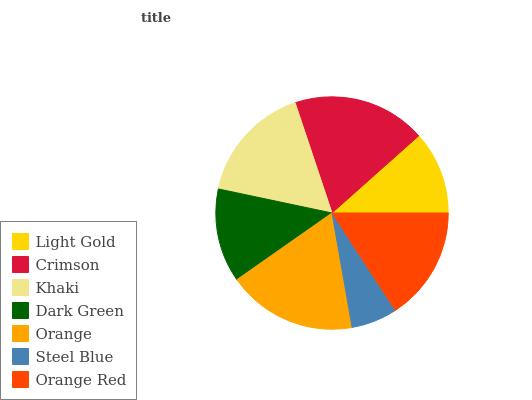Is Steel Blue the minimum?
Answer yes or no. Yes. Is Crimson the maximum?
Answer yes or no. Yes. Is Khaki the minimum?
Answer yes or no. No. Is Khaki the maximum?
Answer yes or no. No. Is Crimson greater than Khaki?
Answer yes or no. Yes. Is Khaki less than Crimson?
Answer yes or no. Yes. Is Khaki greater than Crimson?
Answer yes or no. No. Is Crimson less than Khaki?
Answer yes or no. No. Is Orange Red the high median?
Answer yes or no. Yes. Is Orange Red the low median?
Answer yes or no. Yes. Is Orange the high median?
Answer yes or no. No. Is Steel Blue the low median?
Answer yes or no. No. 